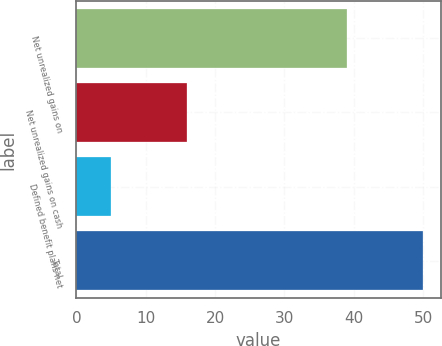Convert chart. <chart><loc_0><loc_0><loc_500><loc_500><bar_chart><fcel>Net unrealized gains on<fcel>Net unrealized gains on cash<fcel>Defined benefit plans net<fcel>Total<nl><fcel>39<fcel>16<fcel>5<fcel>50<nl></chart> 